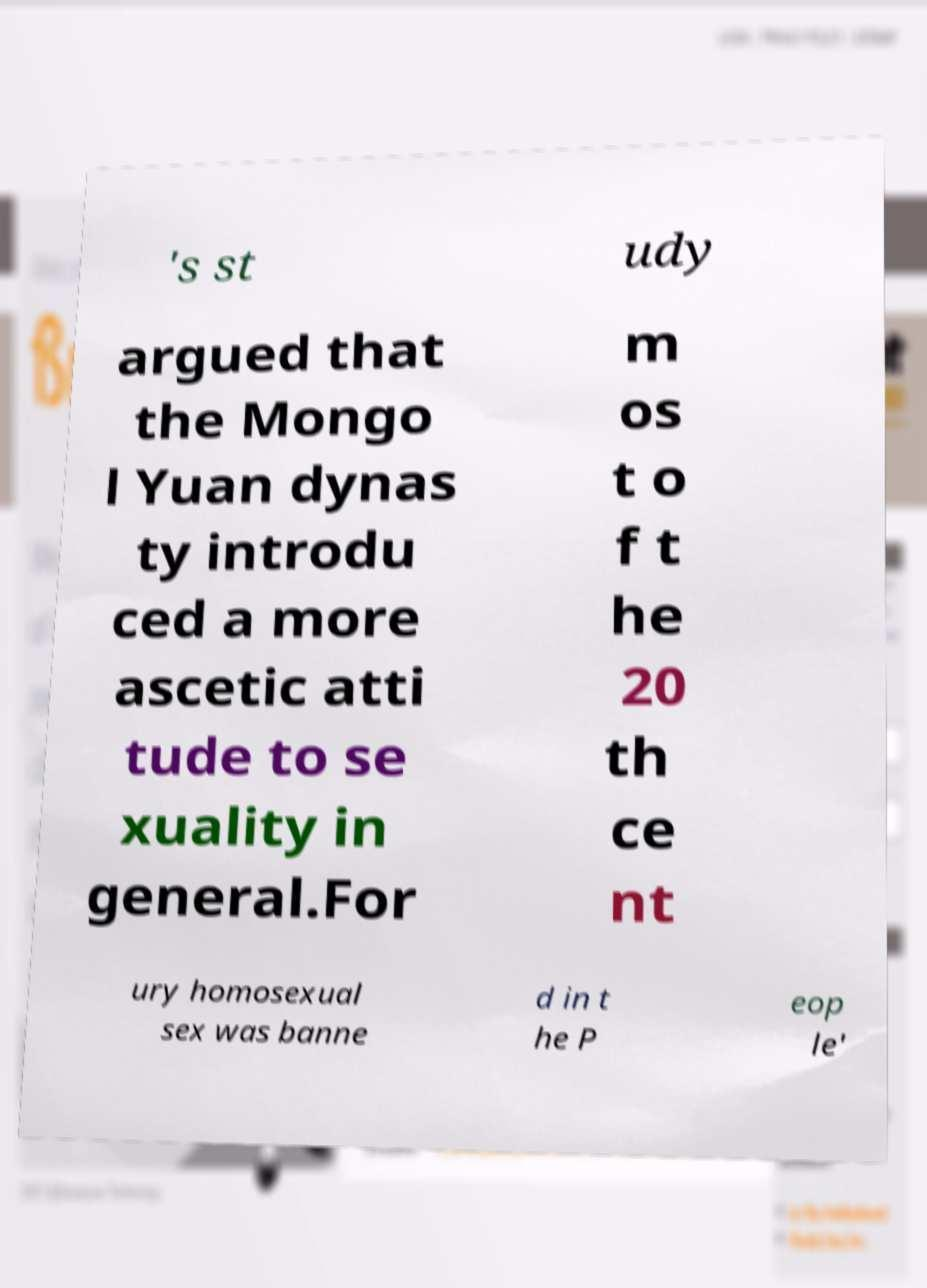There's text embedded in this image that I need extracted. Can you transcribe it verbatim? 's st udy argued that the Mongo l Yuan dynas ty introdu ced a more ascetic atti tude to se xuality in general.For m os t o f t he 20 th ce nt ury homosexual sex was banne d in t he P eop le' 